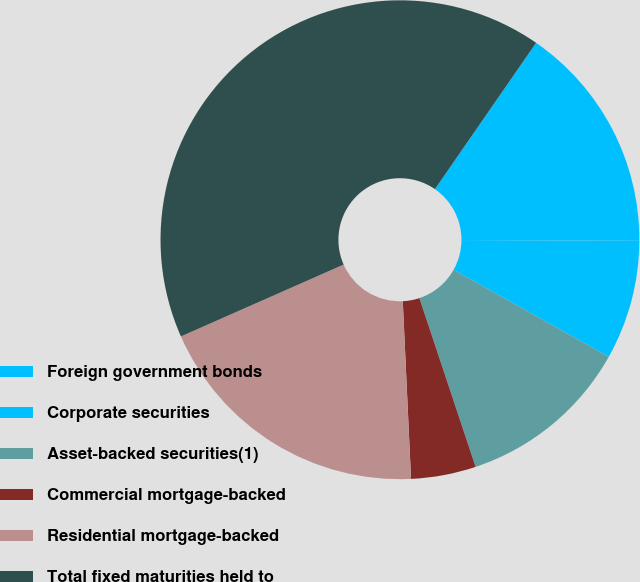Convert chart to OTSL. <chart><loc_0><loc_0><loc_500><loc_500><pie_chart><fcel>Foreign government bonds<fcel>Corporate securities<fcel>Asset-backed securities(1)<fcel>Commercial mortgage-backed<fcel>Residential mortgage-backed<fcel>Total fixed maturities held to<nl><fcel>15.44%<fcel>8.06%<fcel>11.75%<fcel>4.38%<fcel>19.12%<fcel>41.25%<nl></chart> 